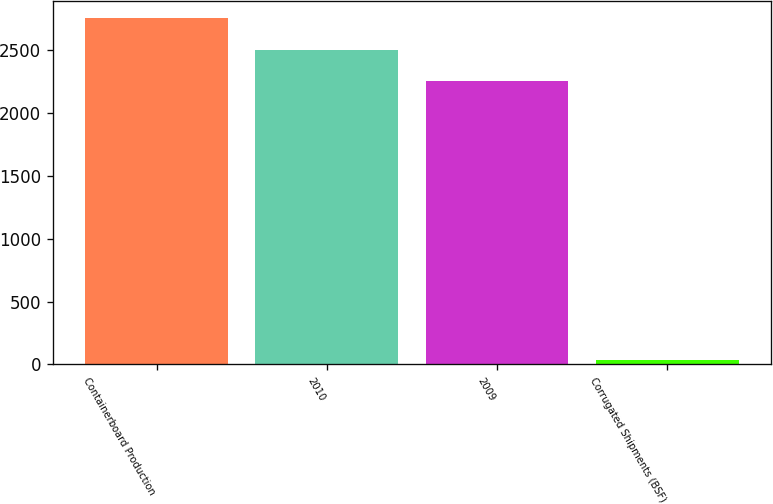Convert chart. <chart><loc_0><loc_0><loc_500><loc_500><bar_chart><fcel>Containerboard Production<fcel>2010<fcel>2009<fcel>Corrugated Shipments (BSF)<nl><fcel>2751.3<fcel>2504.65<fcel>2258<fcel>32.5<nl></chart> 